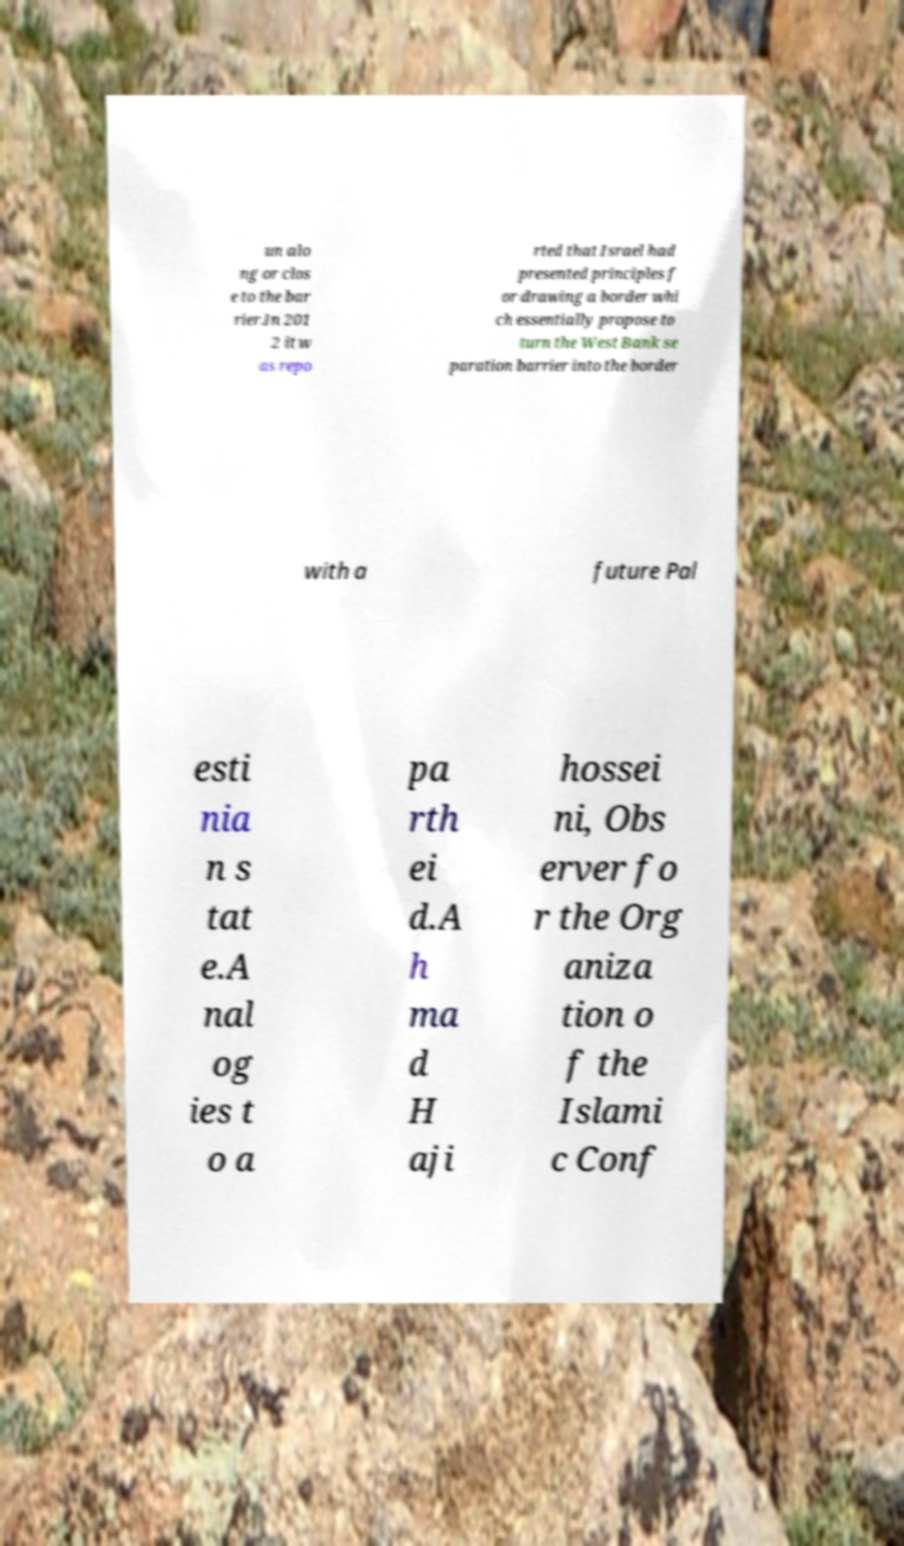There's text embedded in this image that I need extracted. Can you transcribe it verbatim? un alo ng or clos e to the bar rier.In 201 2 it w as repo rted that Israel had presented principles f or drawing a border whi ch essentially propose to turn the West Bank se paration barrier into the border with a future Pal esti nia n s tat e.A nal og ies t o a pa rth ei d.A h ma d H aji hossei ni, Obs erver fo r the Org aniza tion o f the Islami c Conf 